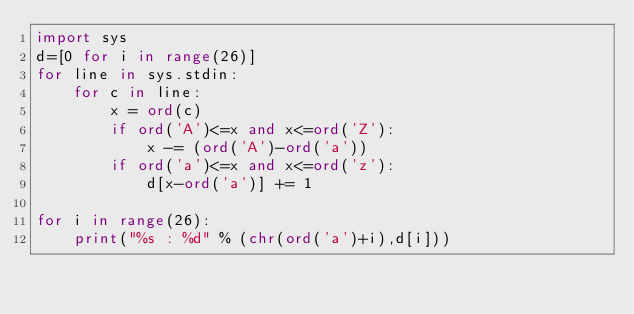Convert code to text. <code><loc_0><loc_0><loc_500><loc_500><_Python_>import sys
d=[0 for i in range(26)]
for line in sys.stdin:
    for c in line:
        x = ord(c)
        if ord('A')<=x and x<=ord('Z'):
            x -= (ord('A')-ord('a'))
        if ord('a')<=x and x<=ord('z'):
            d[x-ord('a')] += 1   

for i in range(26):
    print("%s : %d" % (chr(ord('a')+i),d[i]))</code> 